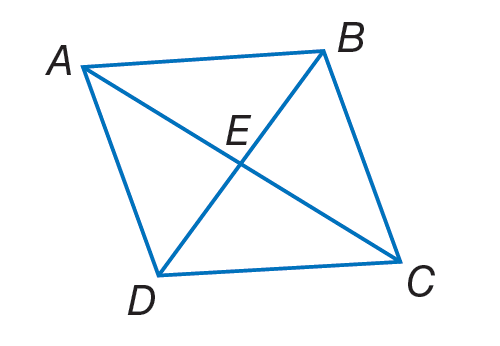Question: A B C D is a rhombus. If E B = 9, A B = 12 and m \angle A B D = 55. Find A E.
Choices:
A. \sqrt { 63 }
B. 8
C. 12.5
D. 81
Answer with the letter. Answer: A Question: A B C D is a rhombus. If E B = 9, A B = 12 and m \angle A B D = 55. Find m \angle B D A.
Choices:
A. 9
B. 12
C. 20
D. 55
Answer with the letter. Answer: D Question: A B C D is a rhombus. If E B = 9, A B = 12 and m \angle A B D = 55. Find m \angle A C B.
Choices:
A. 9
B. 12
C. 21
D. 35
Answer with the letter. Answer: D Question: A B C D is a rhombus. If E B = 9, A B = 12 and m \angle A B D = 55. Find C E.
Choices:
A. \sqrt { 63 }
B. \sqrt { 70 }
C. 9
D. 12
Answer with the letter. Answer: A 